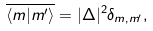<formula> <loc_0><loc_0><loc_500><loc_500>\overline { \langle m | m ^ { \prime } \rangle } = | \Delta | ^ { 2 } \delta _ { m , m ^ { \prime } } ,</formula> 